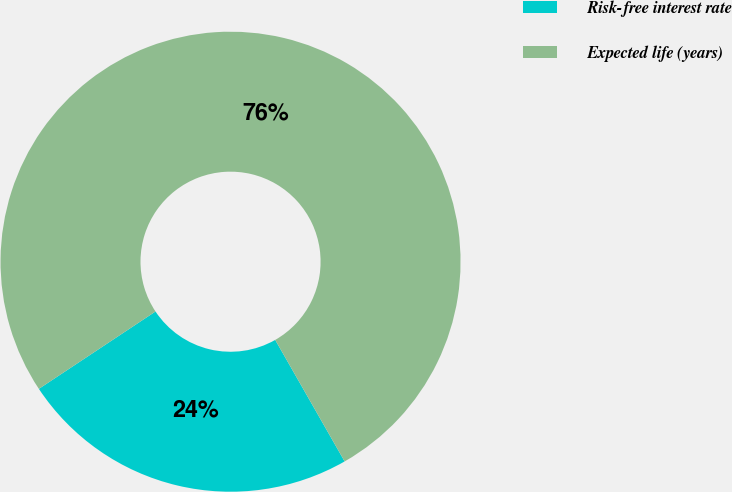Convert chart. <chart><loc_0><loc_0><loc_500><loc_500><pie_chart><fcel>Risk-free interest rate<fcel>Expected life (years)<nl><fcel>23.94%<fcel>76.06%<nl></chart> 